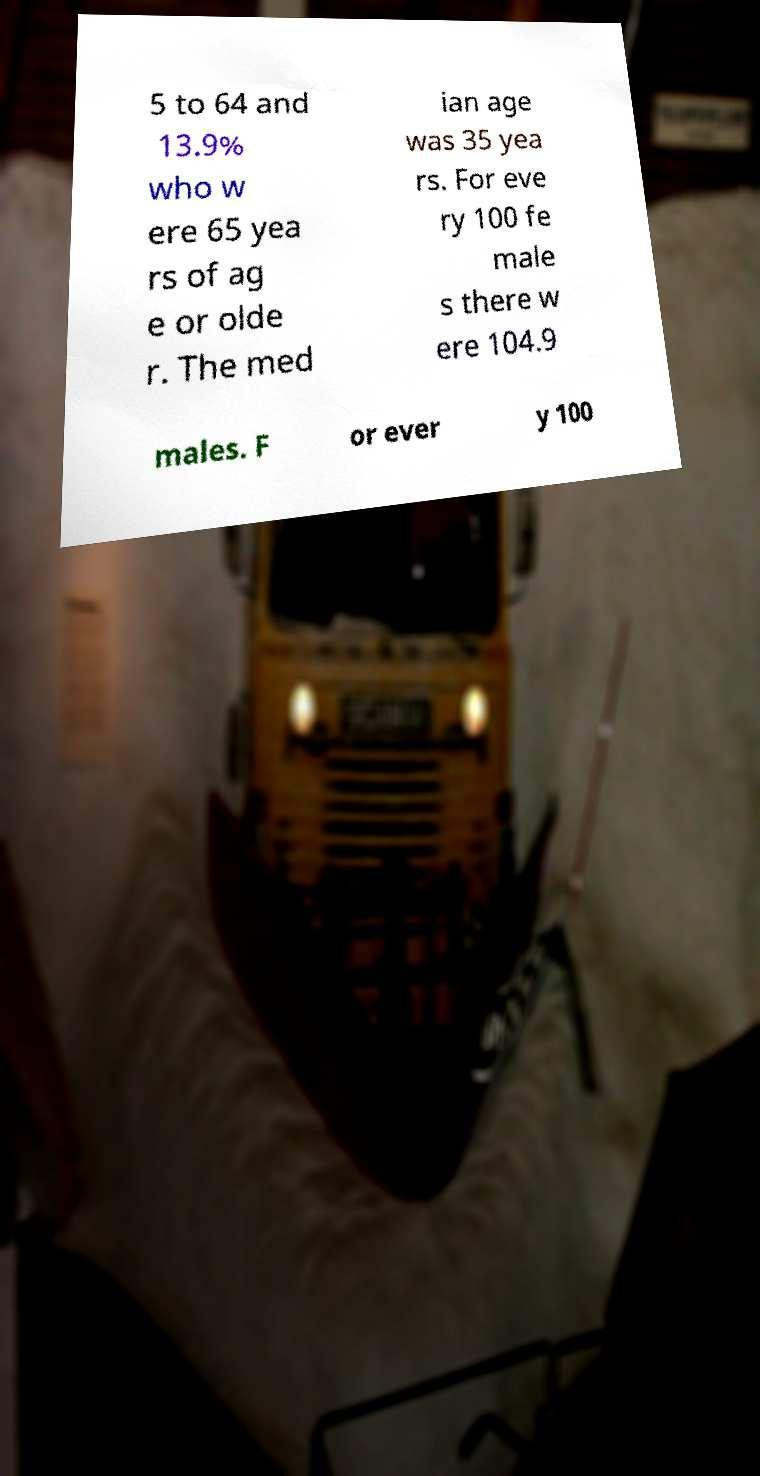What messages or text are displayed in this image? I need them in a readable, typed format. 5 to 64 and 13.9% who w ere 65 yea rs of ag e or olde r. The med ian age was 35 yea rs. For eve ry 100 fe male s there w ere 104.9 males. F or ever y 100 